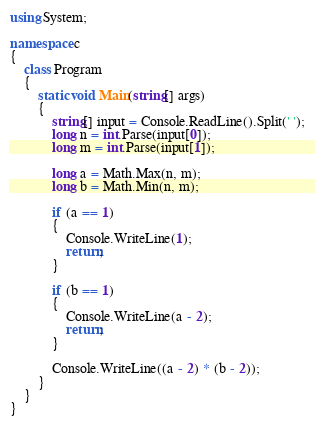<code> <loc_0><loc_0><loc_500><loc_500><_C#_>using System;

namespace c
{
    class Program
    {
        static void Main(string[] args)
        {
            string[] input = Console.ReadLine().Split(' ');
            long n = int.Parse(input[0]);
            long m = int.Parse(input[1]);

            long a = Math.Max(n, m);
            long b = Math.Min(n, m);

            if (a == 1)
            {
                Console.WriteLine(1);
                return;
            }

            if (b == 1)
            {
                Console.WriteLine(a - 2);
                return;
            }
            
            Console.WriteLine((a - 2) * (b - 2));
        }
    }
}</code> 